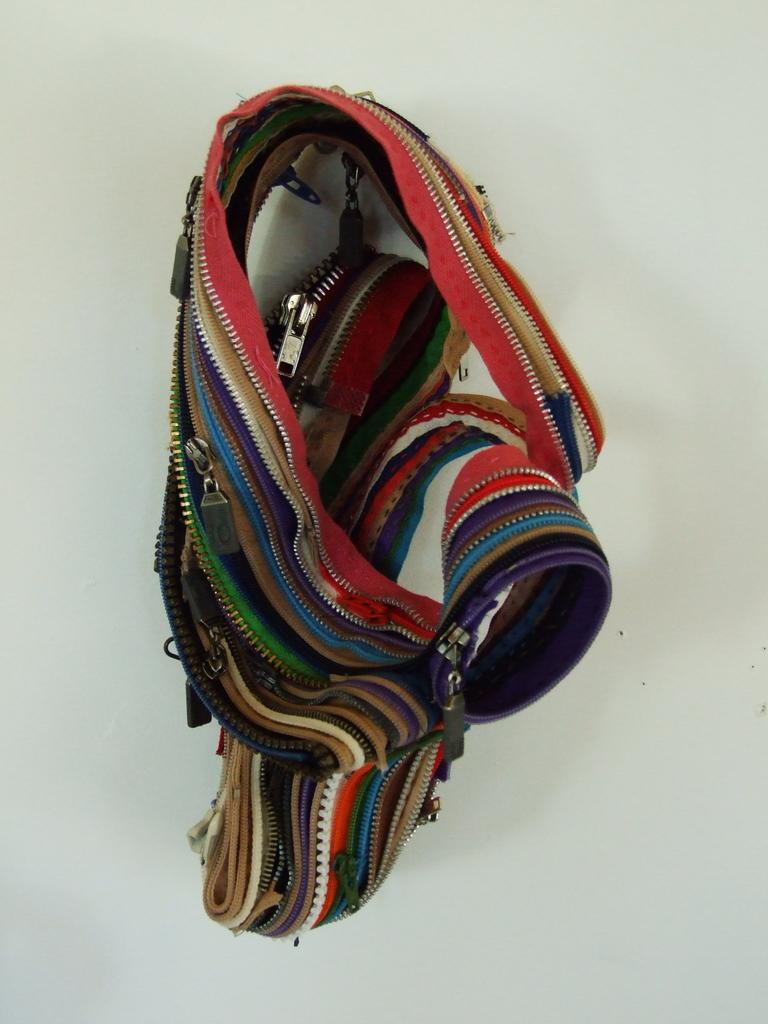What type of bag is visible in the image? There is a belt bag in the image. Where is the belt bag located? The belt bag is on a table. What type of guitar is visible in the image? There is no guitar present in the image; it only features a belt bag on a table. What type of sheet is covering the belt bag in the image? There is no sheet covering the belt bag in the image; it is visible on the table. 